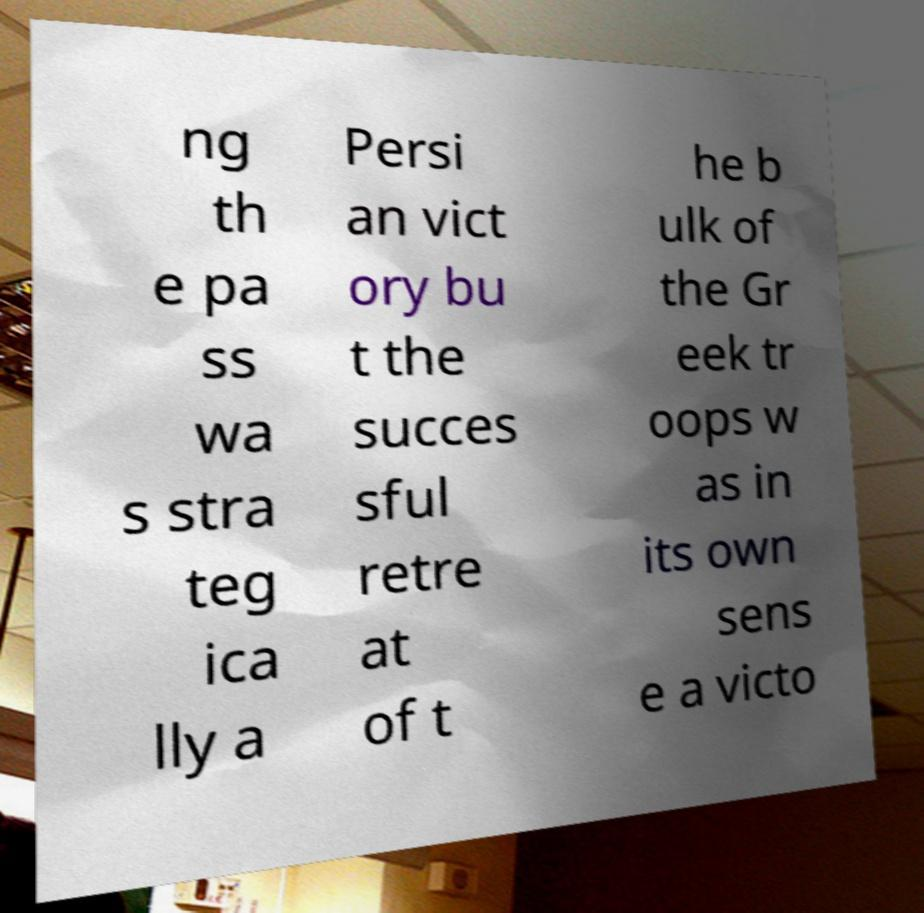Please identify and transcribe the text found in this image. ng th e pa ss wa s stra teg ica lly a Persi an vict ory bu t the succes sful retre at of t he b ulk of the Gr eek tr oops w as in its own sens e a victo 